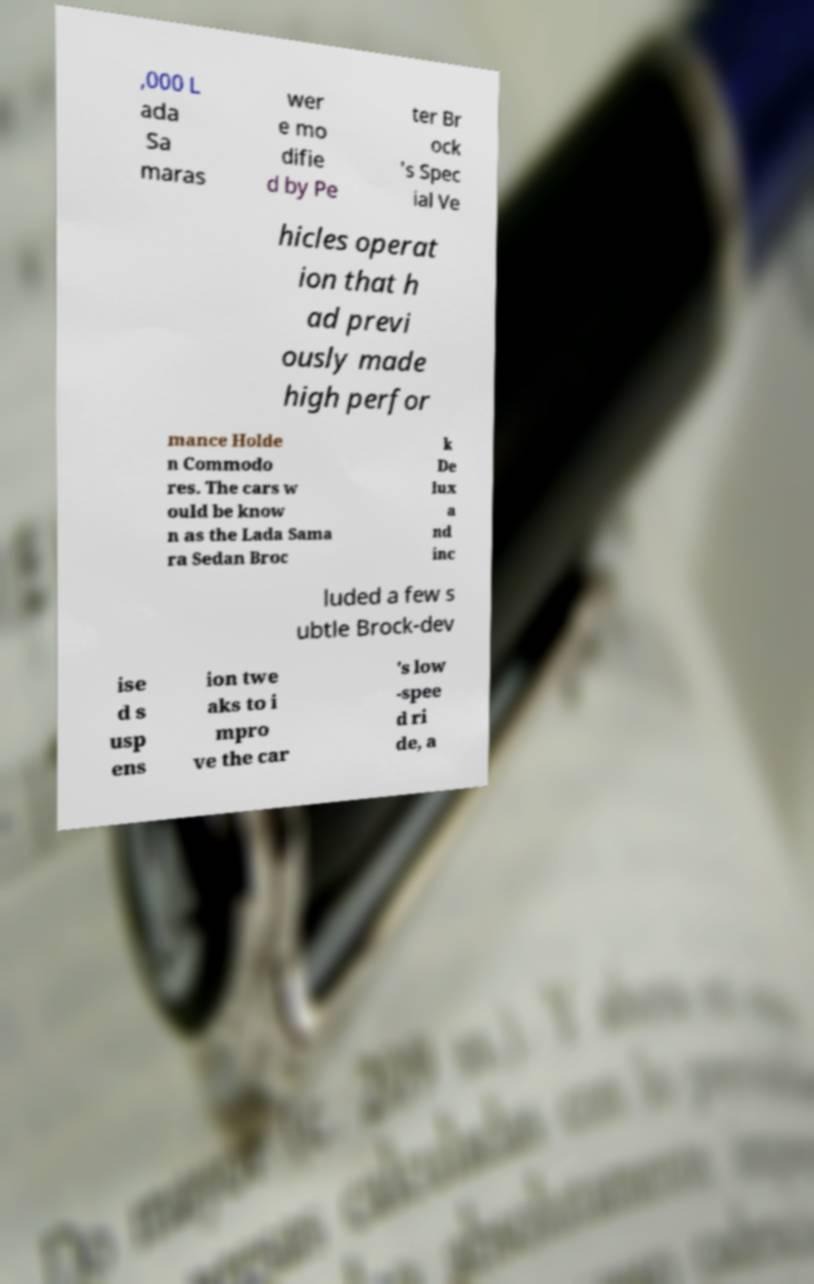Please identify and transcribe the text found in this image. ,000 L ada Sa maras wer e mo difie d by Pe ter Br ock 's Spec ial Ve hicles operat ion that h ad previ ously made high perfor mance Holde n Commodo res. The cars w ould be know n as the Lada Sama ra Sedan Broc k De lux a nd inc luded a few s ubtle Brock-dev ise d s usp ens ion twe aks to i mpro ve the car 's low -spee d ri de, a 